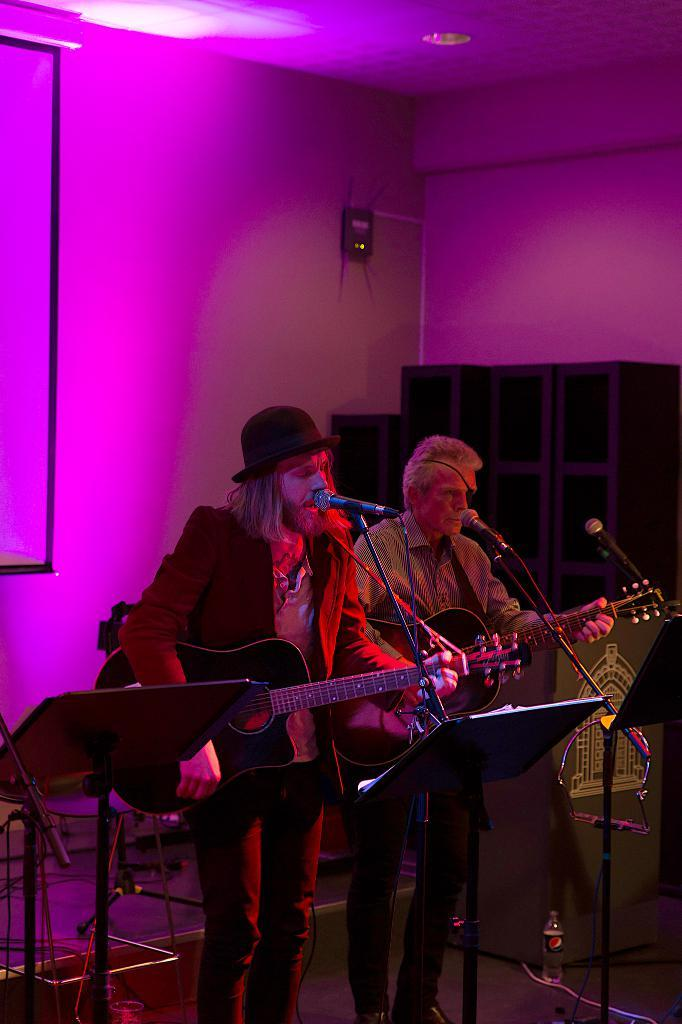How many people are in the image? There are two persons in the image. What are the two persons doing? They are standing, and one of them is playing a guitar. What might the other person be doing? The other person may also be playing a guitar or engaged in a related activity. What can be seen in the background of the image? There is a screen in the background of the image. What type of owl can be seen sitting on the ship in the image? There is no owl or ship present in the image. What role does the representative play in the image? There is no representative mentioned in the image; it features two persons, one playing a guitar and the other possibly engaged in a related activity. 